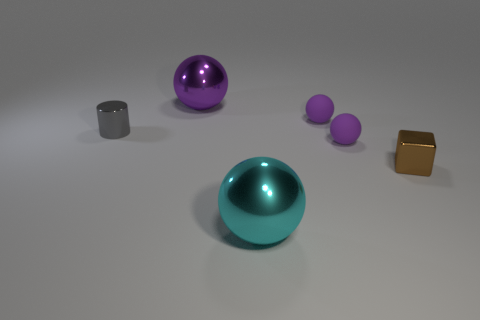Can you guess the context or purpose of the arrangement of these objects? The arrangement of objects seems to have an aesthetic purpose, perhaps for a still life composition or product display. Their placement seems intentional, with enough space between them to provide a clear view of each item, indicating it could be a setup designed for visual appeal or for photographing the objects to highlight their individual characteristics. If this were a product display, what might the products be? If this is a product display, the objects could be decorative items meant to enhance interior spaces. The spheres might be ornamental, possibly functioning as paperweights or simply as artistic elements. The cube and cylinder could serve as containers or stands that complement the spheres, adding to the overall decorative scheme. 